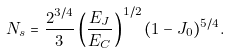<formula> <loc_0><loc_0><loc_500><loc_500>N _ { s } = \frac { 2 ^ { 3 / 4 } } { 3 } \left ( \frac { E _ { J } } { E _ { C } } \right ) ^ { 1 / 2 } ( 1 - J _ { 0 } ) ^ { 5 / 4 } .</formula> 